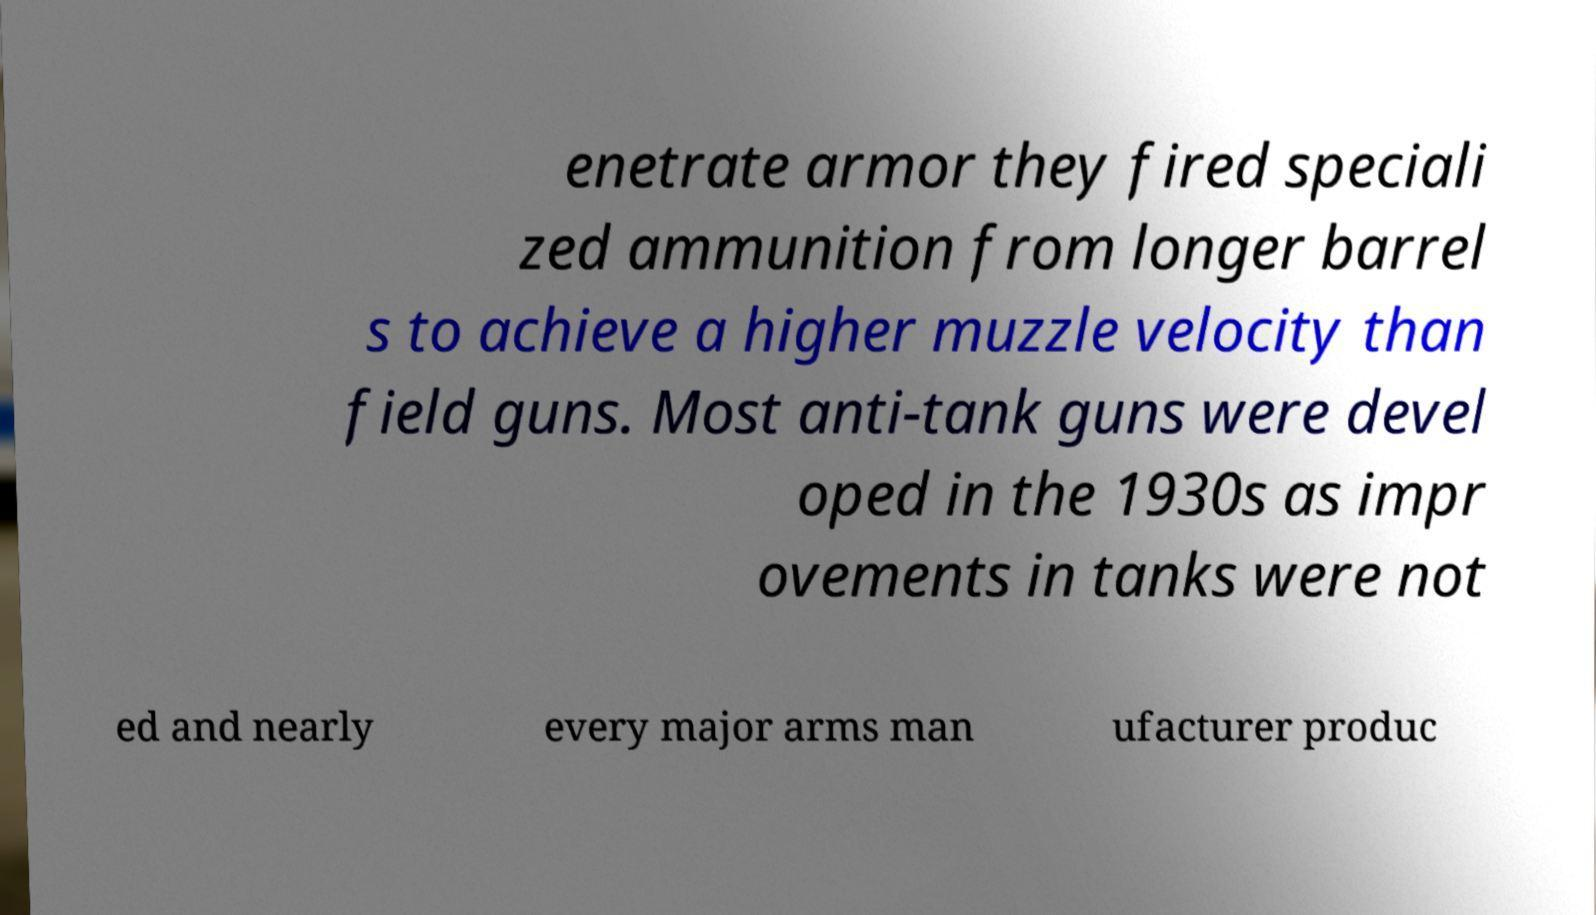There's text embedded in this image that I need extracted. Can you transcribe it verbatim? enetrate armor they fired speciali zed ammunition from longer barrel s to achieve a higher muzzle velocity than field guns. Most anti-tank guns were devel oped in the 1930s as impr ovements in tanks were not ed and nearly every major arms man ufacturer produc 